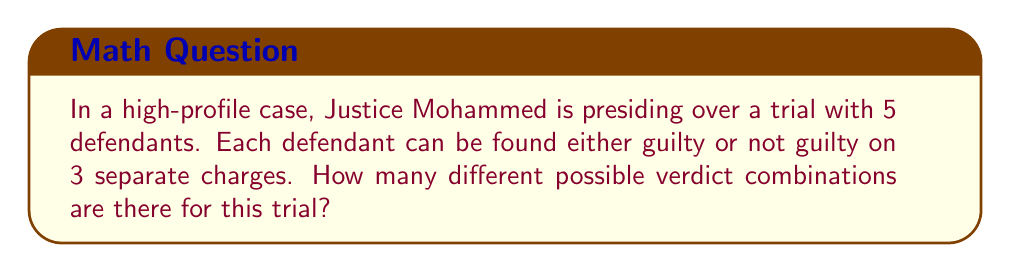Give your solution to this math problem. Let's approach this step-by-step:

1) First, we need to understand what we're counting:
   - There are 5 defendants
   - Each defendant faces 3 charges
   - For each charge, there are 2 possible outcomes (guilty or not guilty)

2) For each defendant:
   - We have 2 choices for the first charge
   - 2 choices for the second charge
   - 2 choices for the third charge
   
   This means for each defendant, there are $2 \times 2 \times 2 = 2^3 = 8$ possible outcome combinations.

3) Now, we need to consider all 5 defendants together:
   - We have 8 possibilities for the first defendant
   - 8 for the second
   - 8 for the third
   - 8 for the fourth
   - 8 for the fifth

4) To get the total number of possible combinations, we multiply these together:

   $$ 8 \times 8 \times 8 \times 8 \times 8 = 8^5 $$

5) We can simplify this further:
   $$ 8^5 = (2^3)^5 = 2^{15} = 32,768 $$

Therefore, there are 32,768 different possible verdict combinations in this trial.
Answer: $2^{15} = 32,768$ 